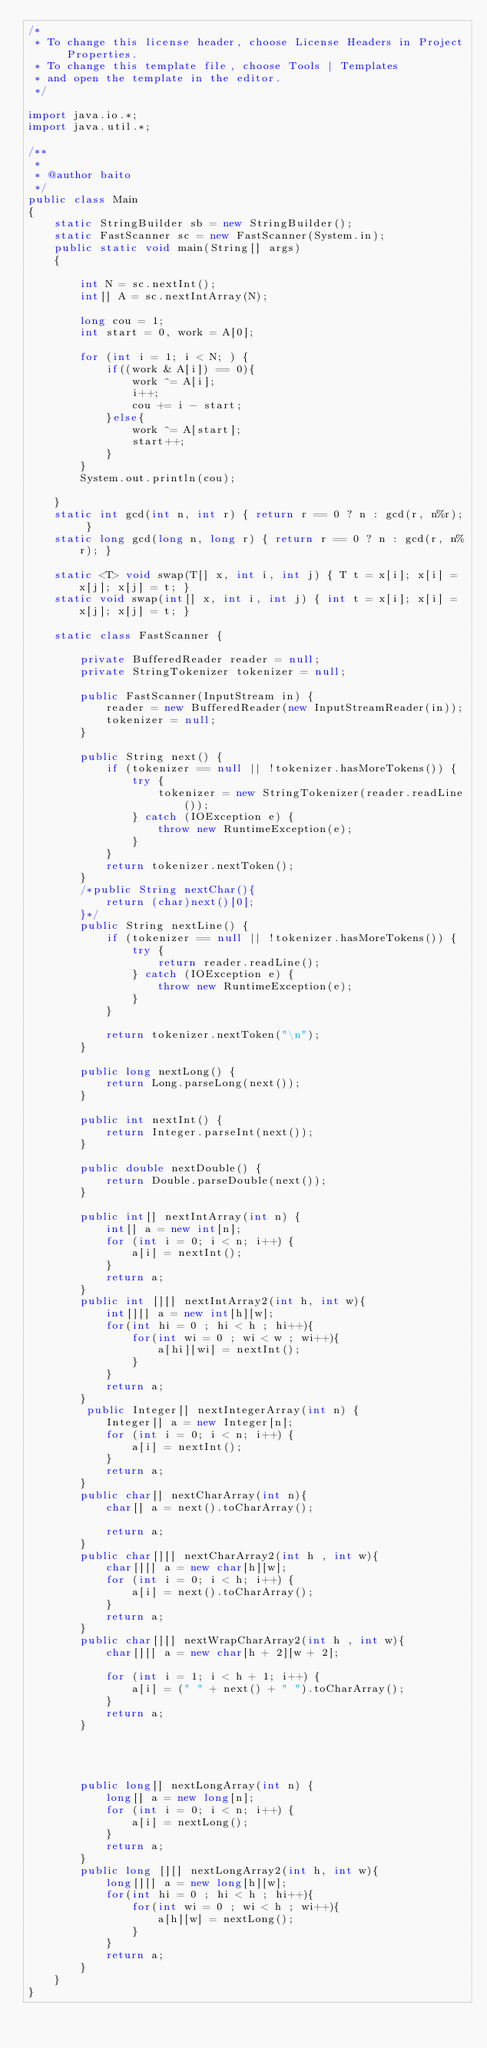Convert code to text. <code><loc_0><loc_0><loc_500><loc_500><_Java_>/*
 * To change this license header, choose License Headers in Project Properties.
 * To change this template file, choose Tools | Templates
 * and open the template in the editor.
 */

import java.io.*;
import java.util.*;

/**
 *
 * @author baito 
 */
public class Main
{
    static StringBuilder sb = new StringBuilder();
    static FastScanner sc = new FastScanner(System.in);
    public static void main(String[] args)
    {
        
        int N = sc.nextInt();
        int[] A = sc.nextIntArray(N);
        
        long cou = 1; 
        int start = 0, work = A[0];
        
        for (int i = 1; i < N; ) {
            if((work & A[i]) == 0){
                work ^= A[i];
                i++;
                cou += i - start;
            }else{
                work ^= A[start];
                start++;
            }
        }
        System.out.println(cou);
        
    }
    static int gcd(int n, int r) { return r == 0 ? n : gcd(r, n%r); }
    static long gcd(long n, long r) { return r == 0 ? n : gcd(r, n%r); }
	
    static <T> void swap(T[] x, int i, int j) { T t = x[i]; x[i] = x[j]; x[j] = t; }
    static void swap(int[] x, int i, int j) { int t = x[i]; x[i] = x[j]; x[j] = t; }
    
    static class FastScanner {

        private BufferedReader reader = null;
        private StringTokenizer tokenizer = null;
        
        public FastScanner(InputStream in) {
            reader = new BufferedReader(new InputStreamReader(in));
            tokenizer = null;
        }
        
        public String next() {
            if (tokenizer == null || !tokenizer.hasMoreTokens()) {
                try {
                    tokenizer = new StringTokenizer(reader.readLine());
                } catch (IOException e) {
                    throw new RuntimeException(e);
                }
            }
            return tokenizer.nextToken();
        }
        /*public String nextChar(){
            return (char)next()[0];
        }*/
        public String nextLine() {
            if (tokenizer == null || !tokenizer.hasMoreTokens()) {
                try {
                    return reader.readLine();
                } catch (IOException e) {
                    throw new RuntimeException(e);
                }
            }
            
            return tokenizer.nextToken("\n");
        }
        
        public long nextLong() {
            return Long.parseLong(next());
        }
        
        public int nextInt() {
            return Integer.parseInt(next());
        }
        
        public double nextDouble() {
            return Double.parseDouble(next());
        }
        
        public int[] nextIntArray(int n) {
            int[] a = new int[n];
            for (int i = 0; i < n; i++) {
                a[i] = nextInt();
            }
            return a;
        }
        public int [][] nextIntArray2(int h, int w){
            int[][] a = new int[h][w];
            for(int hi = 0 ; hi < h ; hi++){
                for(int wi = 0 ; wi < w ; wi++){
                    a[hi][wi] = nextInt();
                }
            }
            return a;
        }
         public Integer[] nextIntegerArray(int n) {
            Integer[] a = new Integer[n];
            for (int i = 0; i < n; i++) {
                a[i] = nextInt();
            }
            return a;
        }
        public char[] nextCharArray(int n){
            char[] a = next().toCharArray();
            
            return a;
        }
        public char[][] nextCharArray2(int h , int w){
            char[][] a = new char[h][w];
            for (int i = 0; i < h; i++) {
                a[i] = next().toCharArray();
            }
            return a;
        }
        public char[][] nextWrapCharArray2(int h , int w){
            char[][] a = new char[h + 2][w + 2];
            
            for (int i = 1; i < h + 1; i++) {
                a[i] = (" " + next() + " ").toCharArray();
            }
            return a;
        }
        
        
       
        
        public long[] nextLongArray(int n) {
            long[] a = new long[n];
            for (int i = 0; i < n; i++) {
                a[i] = nextLong();
            }
            return a;
        }
        public long [][] nextLongArray2(int h, int w){
            long[][] a = new long[h][w];
            for(int hi = 0 ; hi < h ; hi++){
                for(int wi = 0 ; wi < h ; wi++){
                    a[h][w] = nextLong();
                }
            }
            return a;
        }
    }
}
</code> 